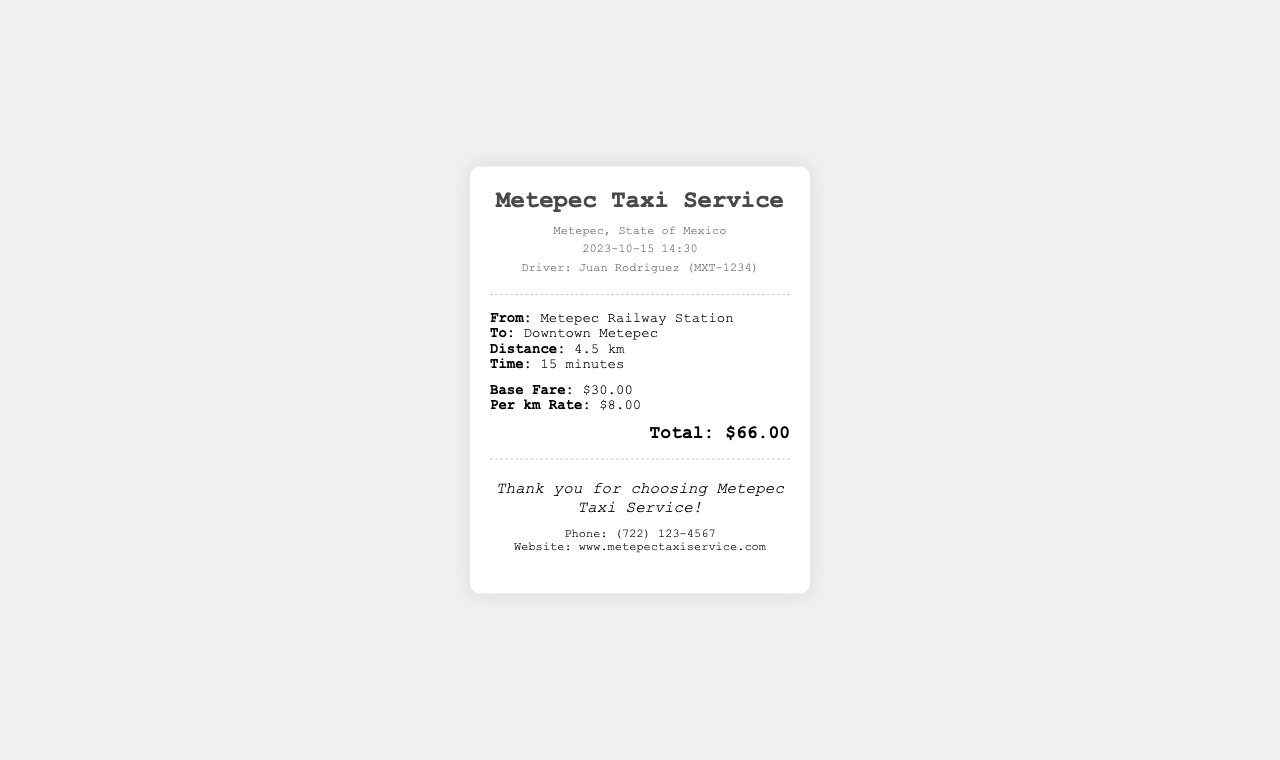What is the date and time of the trip? The date and time of the trip is provided in the receipt under "date-time," which shows 2023-10-15 14:30.
Answer: 2023-10-15 14:30 What is the name of the driver? The driver's name is listed in the driver information section, which states "Driver: Juan Rodriguez."
Answer: Juan Rodriguez What is the distance traveled? The distance for the trip is specified in the trip details, indicating "Distance: 4.5 km."
Answer: 4.5 km How much is the base fare? The base fare is mentioned in the fare information section of the receipt as "$30.00."
Answer: $30.00 What is the total fare for the trip? The total fare is clearly stated in the total fare section, showing "Total: $66.00."
Answer: $66.00 If the distance is 4.5 km and the per km rate is $8.00, what is the fare calculated just based on distance? The fare based on distance can be calculated by multiplying the distance by the per km rate, which is 4.5 km x $8.00 = $36.00.
Answer: $36.00 From where to where is the trip? The trip's start and end locations are provided in the trip info, stating "From: Metepec Railway Station" and "To: Downtown Metepec."
Answer: Metepec Railway Station to Downtown Metepec What is the contact number provided in the receipt? The contact number is mentioned in the footer section of the receipt, listing "Phone: (722) 123-4567."
Answer: (722) 123-4567 What is the website for the taxi service? The website can be found in the footer section of the receipt, which states "Website: www.metepectaxiservice.com."
Answer: www.metepectaxiservice.com 